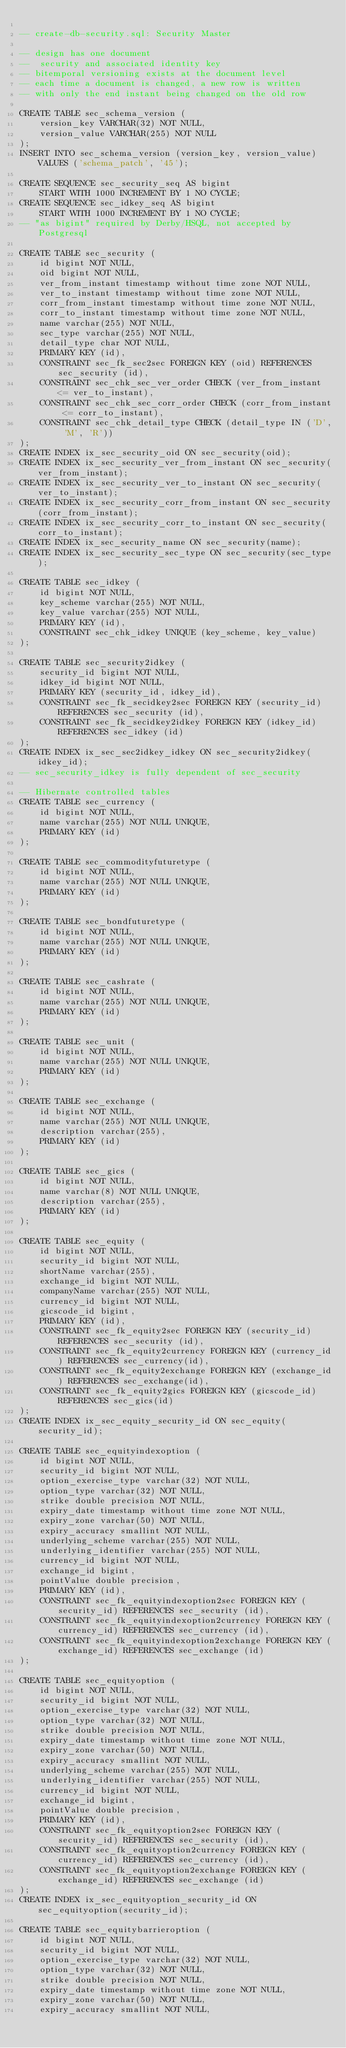<code> <loc_0><loc_0><loc_500><loc_500><_SQL_>
-- create-db-security.sql: Security Master

-- design has one document
--  security and associated identity key
-- bitemporal versioning exists at the document level
-- each time a document is changed, a new row is written
-- with only the end instant being changed on the old row

CREATE TABLE sec_schema_version (
    version_key VARCHAR(32) NOT NULL,
    version_value VARCHAR(255) NOT NULL
);
INSERT INTO sec_schema_version (version_key, version_value) VALUES ('schema_patch', '45');

CREATE SEQUENCE sec_security_seq AS bigint
    START WITH 1000 INCREMENT BY 1 NO CYCLE;
CREATE SEQUENCE sec_idkey_seq AS bigint
    START WITH 1000 INCREMENT BY 1 NO CYCLE;
-- "as bigint" required by Derby/HSQL, not accepted by Postgresql

CREATE TABLE sec_security (
    id bigint NOT NULL,
    oid bigint NOT NULL,
    ver_from_instant timestamp without time zone NOT NULL,
    ver_to_instant timestamp without time zone NOT NULL,
    corr_from_instant timestamp without time zone NOT NULL,
    corr_to_instant timestamp without time zone NOT NULL,
    name varchar(255) NOT NULL,
    sec_type varchar(255) NOT NULL,
    detail_type char NOT NULL,
    PRIMARY KEY (id),
    CONSTRAINT sec_fk_sec2sec FOREIGN KEY (oid) REFERENCES sec_security (id),
    CONSTRAINT sec_chk_sec_ver_order CHECK (ver_from_instant <= ver_to_instant),
    CONSTRAINT sec_chk_sec_corr_order CHECK (corr_from_instant <= corr_to_instant),
    CONSTRAINT sec_chk_detail_type CHECK (detail_type IN ('D', 'M', 'R'))
);
CREATE INDEX ix_sec_security_oid ON sec_security(oid);
CREATE INDEX ix_sec_security_ver_from_instant ON sec_security(ver_from_instant);
CREATE INDEX ix_sec_security_ver_to_instant ON sec_security(ver_to_instant);
CREATE INDEX ix_sec_security_corr_from_instant ON sec_security(corr_from_instant);
CREATE INDEX ix_sec_security_corr_to_instant ON sec_security(corr_to_instant);
CREATE INDEX ix_sec_security_name ON sec_security(name);
CREATE INDEX ix_sec_security_sec_type ON sec_security(sec_type);

CREATE TABLE sec_idkey (
    id bigint NOT NULL,
    key_scheme varchar(255) NOT NULL,
    key_value varchar(255) NOT NULL,
    PRIMARY KEY (id),
    CONSTRAINT sec_chk_idkey UNIQUE (key_scheme, key_value)
);

CREATE TABLE sec_security2idkey (
    security_id bigint NOT NULL,
    idkey_id bigint NOT NULL,
    PRIMARY KEY (security_id, idkey_id),
    CONSTRAINT sec_fk_secidkey2sec FOREIGN KEY (security_id) REFERENCES sec_security (id),
    CONSTRAINT sec_fk_secidkey2idkey FOREIGN KEY (idkey_id) REFERENCES sec_idkey (id)
);
CREATE INDEX ix_sec_sec2idkey_idkey ON sec_security2idkey(idkey_id);
-- sec_security_idkey is fully dependent of sec_security

-- Hibernate controlled tables
CREATE TABLE sec_currency (
    id bigint NOT NULL,
    name varchar(255) NOT NULL UNIQUE,
    PRIMARY KEY (id)
);

CREATE TABLE sec_commodityfuturetype (
    id bigint NOT NULL,
    name varchar(255) NOT NULL UNIQUE,
    PRIMARY KEY (id)
);

CREATE TABLE sec_bondfuturetype (
    id bigint NOT NULL,
    name varchar(255) NOT NULL UNIQUE,
    PRIMARY KEY (id)
);

CREATE TABLE sec_cashrate (
    id bigint NOT NULL,
    name varchar(255) NOT NULL UNIQUE,
    PRIMARY KEY (id)
);

CREATE TABLE sec_unit (
    id bigint NOT NULL,
    name varchar(255) NOT NULL UNIQUE,
    PRIMARY KEY (id)
);

CREATE TABLE sec_exchange (
    id bigint NOT NULL,
    name varchar(255) NOT NULL UNIQUE,
    description varchar(255),
    PRIMARY KEY (id)
);

CREATE TABLE sec_gics (
    id bigint NOT NULL,
    name varchar(8) NOT NULL UNIQUE,
    description varchar(255),
    PRIMARY KEY (id)
);

CREATE TABLE sec_equity (
    id bigint NOT NULL,
    security_id bigint NOT NULL,
    shortName varchar(255),
    exchange_id bigint NOT NULL,
    companyName varchar(255) NOT NULL,
    currency_id bigint NOT NULL,
    gicscode_id bigint,
    PRIMARY KEY (id),
    CONSTRAINT sec_fk_equity2sec FOREIGN KEY (security_id) REFERENCES sec_security (id),
    CONSTRAINT sec_fk_equity2currency FOREIGN KEY (currency_id) REFERENCES sec_currency(id),
    CONSTRAINT sec_fk_equity2exchange FOREIGN KEY (exchange_id) REFERENCES sec_exchange(id),
    CONSTRAINT sec_fk_equity2gics FOREIGN KEY (gicscode_id) REFERENCES sec_gics(id)
);
CREATE INDEX ix_sec_equity_security_id ON sec_equity(security_id);

CREATE TABLE sec_equityindexoption (
    id bigint NOT NULL,
    security_id bigint NOT NULL,
    option_exercise_type varchar(32) NOT NULL,
    option_type varchar(32) NOT NULL,
    strike double precision NOT NULL,
    expiry_date timestamp without time zone NOT NULL,
    expiry_zone varchar(50) NOT NULL,
    expiry_accuracy smallint NOT NULL,
    underlying_scheme varchar(255) NOT NULL,
    underlying_identifier varchar(255) NOT NULL,
    currency_id bigint NOT NULL,
    exchange_id bigint,
    pointValue double precision,
    PRIMARY KEY (id),
    CONSTRAINT sec_fk_equityindexoption2sec FOREIGN KEY (security_id) REFERENCES sec_security (id),
    CONSTRAINT sec_fk_equityindexoption2currency FOREIGN KEY (currency_id) REFERENCES sec_currency (id),
    CONSTRAINT sec_fk_equityindexoption2exchange FOREIGN KEY (exchange_id) REFERENCES sec_exchange (id)
);

CREATE TABLE sec_equityoption (
    id bigint NOT NULL,
    security_id bigint NOT NULL,
    option_exercise_type varchar(32) NOT NULL,
    option_type varchar(32) NOT NULL,
    strike double precision NOT NULL,
    expiry_date timestamp without time zone NOT NULL,
    expiry_zone varchar(50) NOT NULL,
    expiry_accuracy smallint NOT NULL,
    underlying_scheme varchar(255) NOT NULL,
    underlying_identifier varchar(255) NOT NULL,
    currency_id bigint NOT NULL,
    exchange_id bigint,
    pointValue double precision,
    PRIMARY KEY (id),
    CONSTRAINT sec_fk_equityoption2sec FOREIGN KEY (security_id) REFERENCES sec_security (id),
    CONSTRAINT sec_fk_equityoption2currency FOREIGN KEY (currency_id) REFERENCES sec_currency (id),
    CONSTRAINT sec_fk_equityoption2exchange FOREIGN KEY (exchange_id) REFERENCES sec_exchange (id)
);
CREATE INDEX ix_sec_equityoption_security_id ON sec_equityoption(security_id);

CREATE TABLE sec_equitybarrieroption (
    id bigint NOT NULL,
    security_id bigint NOT NULL,
    option_exercise_type varchar(32) NOT NULL,
    option_type varchar(32) NOT NULL,
    strike double precision NOT NULL,
    expiry_date timestamp without time zone NOT NULL,
    expiry_zone varchar(50) NOT NULL,
    expiry_accuracy smallint NOT NULL,</code> 